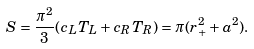<formula> <loc_0><loc_0><loc_500><loc_500>S = \frac { \pi ^ { 2 } } 3 ( c _ { L } T _ { L } + c _ { R } T _ { R } ) = \pi ( r _ { + } ^ { 2 } + a ^ { 2 } ) .</formula> 